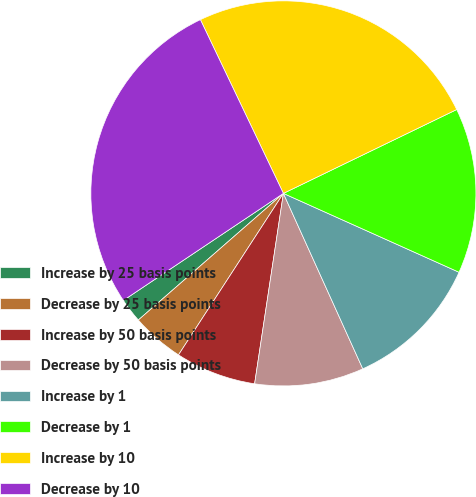Convert chart. <chart><loc_0><loc_0><loc_500><loc_500><pie_chart><fcel>Increase by 25 basis points<fcel>Decrease by 25 basis points<fcel>Increase by 50 basis points<fcel>Decrease by 50 basis points<fcel>Increase by 1<fcel>Decrease by 1<fcel>Increase by 10<fcel>Decrease by 10<nl><fcel>2.04%<fcel>4.41%<fcel>6.78%<fcel>9.15%<fcel>11.52%<fcel>13.89%<fcel>24.92%<fcel>27.29%<nl></chart> 